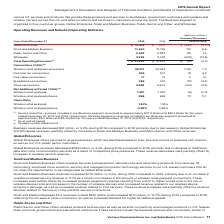From Verizon Communications's financial document, How much did Service and other revenues amounted for   years ended December 31, 2019 and 2018 respectively? The document shows two values: $27.9 billion and $28.1 billion. From the document: "in our Business segment amounted to approximately $27.9 billion and $28.1 billion for the years ended December 31, 2019 and 2018, respectively. Wirele..." Also, How much did Wireless equipment revenues amounted for   years ended December 31, 2019 and 2018 respectively? The document shows two values: $3.5 billion and $3.4 billion. From the document: "segment amounted to approximately $3.5 billion and $3.4 billion for the years ended December 31, 2019 and 2018, respectively. (2) As of end of period ..." Also, Why did Business revenues decrease during 2019? due to decreases in Global Enterprise and Wholesale revenues, partially offset by increases in Small and Medium Business and Public Sector and Other revenues.. The document states: ", or 0.3%, during 2019 compared to 2018, primarily due to decreases in Global Enterprise and Wholesale revenues, partially offset by increases in Smal..." Also, can you calculate: What is the change in Global Enterprise value from 2018 to 2019? Based on the calculation: 10,818-11,201, the result is -383 (in millions). This is based on the information: "Global Enterprise $ 10,818 $ 11,201 $ (383) (3.4)% Global Enterprise $ 10,818 $ 11,201 $ (383) (3.4)%..." The key data points involved are: 10,818, 11,201. Also, can you calculate: What is the change in Small and Medium Business value from 2018 to 2019? Based on the calculation: 11,464-10,752, the result is 712 (in millions). This is based on the information: "Small and Medium Business 11,464 10,752 712 6.6 Small and Medium Business 11,464 10,752 712 6.6..." The key data points involved are: 10,752, 11,464. Also, can you calculate: What is the change in Wholesale value from 2018 to 2019? Based on the calculation: 3,239-3,748, the result is -509 (in millions). This is based on the information: "Wholesale 3,239 3,748 (509) (13.6) Wholesale 3,239 3,748 (509) (13.6)..." The key data points involved are: 3,239, 3,748. 